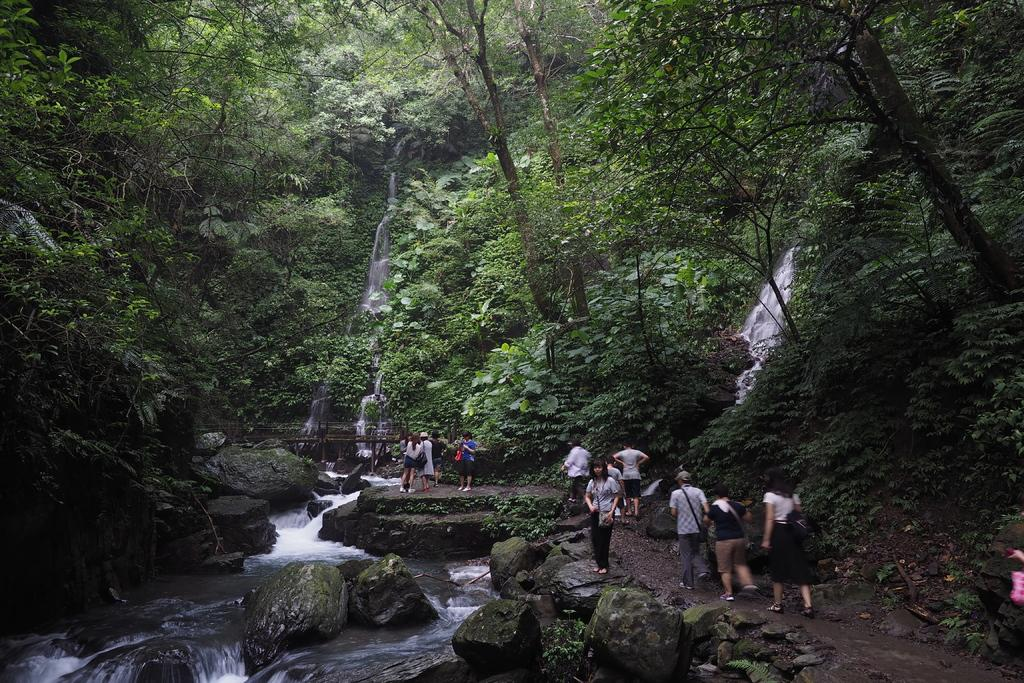What is happening in the image? There is a group of people standing in the image. What can be seen on the left side of the image? There is water and rocks on the left side of the image. What is visible in the background of the image? There are trees visible in the background of the image. What type of iron is being used by the people in the image? There is no iron present in the image; it features a group of people standing near water and rocks. 